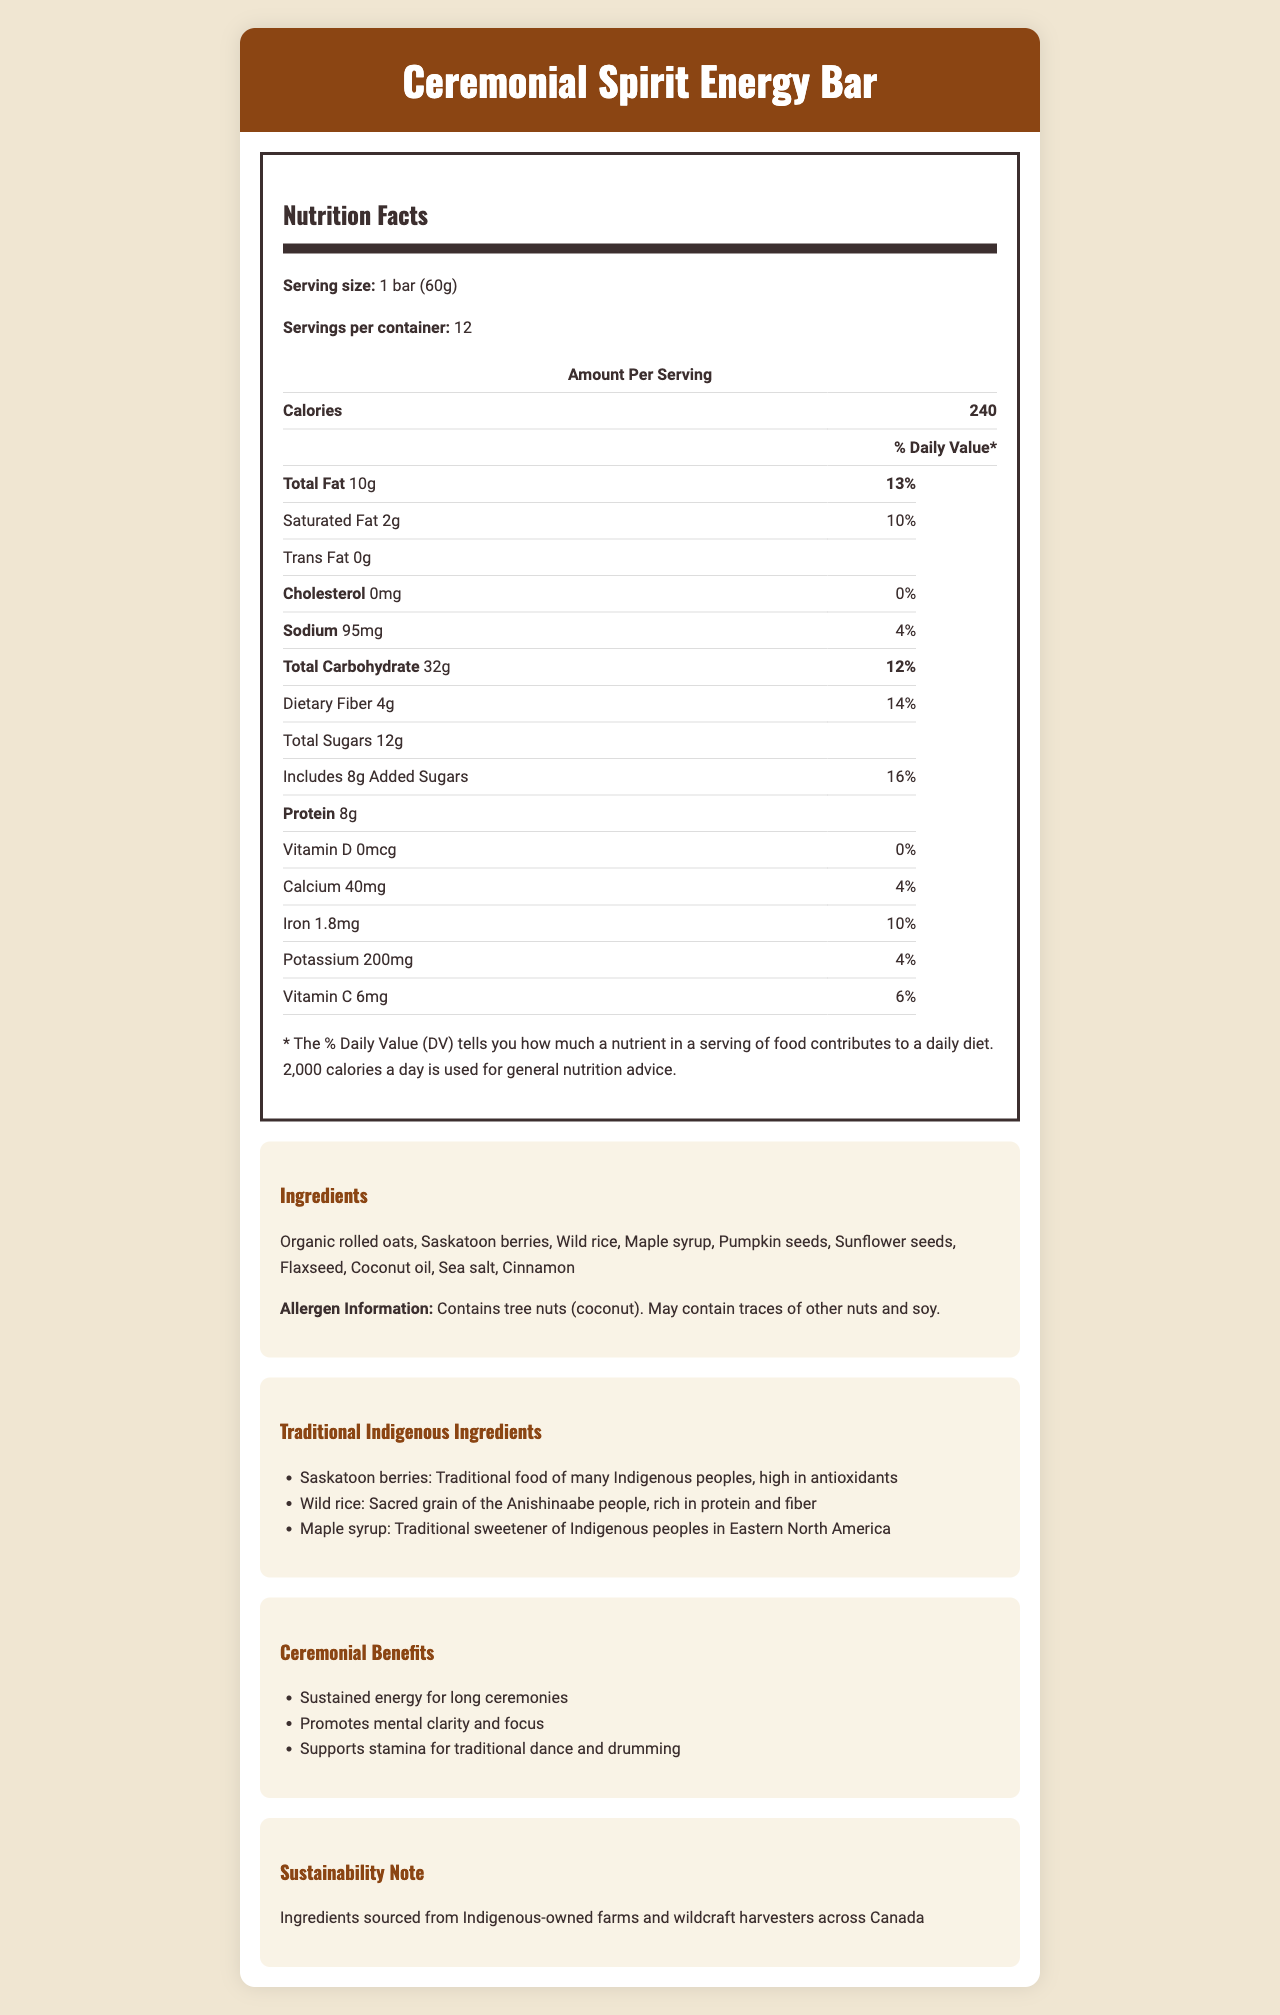what is the serving size for the Ceremonial Spirit Energy Bar? The serving size information is stated at the beginning of the Nutrition Facts section.
Answer: 1 bar (60g) how many servings are there per container? The document states there are 12 servings per container.
Answer: 12 how many calories are in one serving of the energy bar? The number of calories per serving is listed as 240 calories.
Answer: 240 what is the total amount of carbohydrates in one serving? The total carbohydrate content is given as 32g.
Answer: 32g what is the percent daily value of dietary fiber in one serving? The percent daily value for dietary fiber is listed as 14%.
Answer: 14% how much protein does one bar contain? The protein content per serving is given as 8g.
Answer: 8g does the energy bar contain any trans fat? The document specifies that there is 0g of trans fat in the bar.
Answer: No, 0g which of the following traditional ingredients is NOT listed in the bar? A. Saskatoon berries B. Wild rice C. Maple syrup D. Blue corn Blue corn is not listed among the traditional ingredients mentioned: Saskatoon berries, wild rice, and maple syrup.
Answer: D. Blue corn what ingredient provides a traditional sweetener in the energy bar? A. Maple syrup B. Honey C. Agave nectar D. Molasses The traditional sweetener mentioned is maple syrup.
Answer: A. Maple syrup is the Ceremonial Spirit Energy Bar considered a source of calcium? The bar contains 40mg of calcium, which provides 4% of the daily value.
Answer: Yes describe the main idea of the document. The document outlines the nutritional facts, lists the ingredients with a focus on traditional Indigenous ingredients, describes the ceremonial benefits, and emphasizes the sustainability of its sources.
Answer: The document provides the nutritional information, ingredients, traditional ingredients, ceremonial benefits, and sustainability note for the Ceremonial Spirit Energy Bar designed for Indigenous performers. what information about the manufacturing process of the energy bar is given? The document doesn't provide any details about the manufacturing process itself, only the ingredients and their sources.
Answer: Cannot be determined 